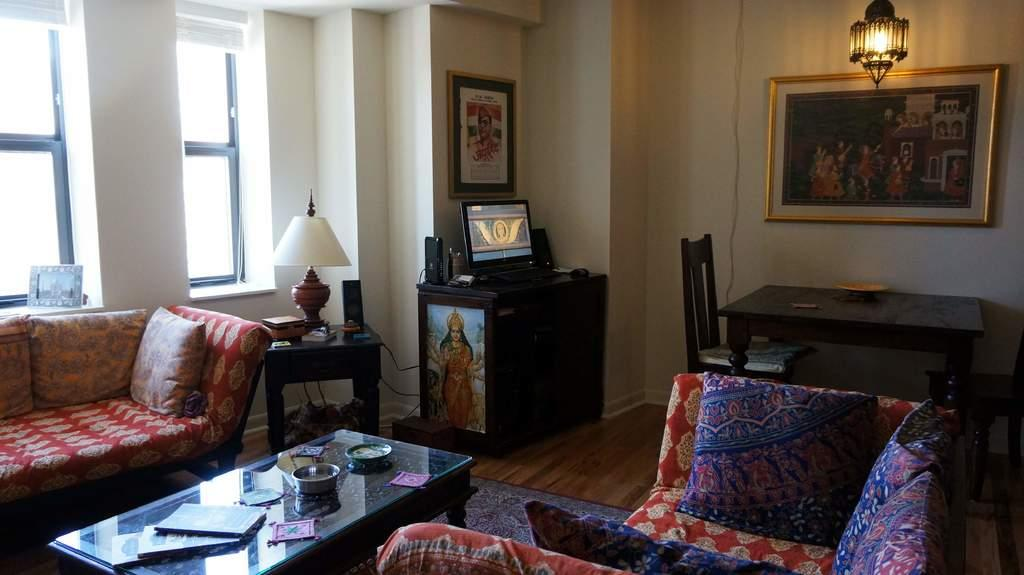What type of structure can be seen in the image? There is a wall in the image. What feature allows light and air into the space? There is a window in the image. What type of decorative item is present in the image? There is a photo frame in the image. What type of lighting fixture is visible in the image? There is a lamp in the image. What type of seating is available in the image? There is a sofa in the image. What type of furniture is present in the image? There is a table in the image. What items can be seen on the table in the image? There are bowls and books on the table in the image. What type of glue is being used in the discussion in the image? There is no discussion or glue present in the image. What type of room is depicted in the image? The image does not depict a specific room; it only shows a wall, window, photo frame, lamp, sofa, table, bowls, and books. 